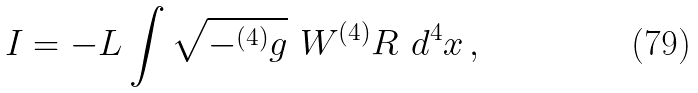<formula> <loc_0><loc_0><loc_500><loc_500>I = - L \int \sqrt { - ^ { ( 4 ) } g } \ W ^ { ( 4 ) } R \ d ^ { 4 } x \, ,</formula> 